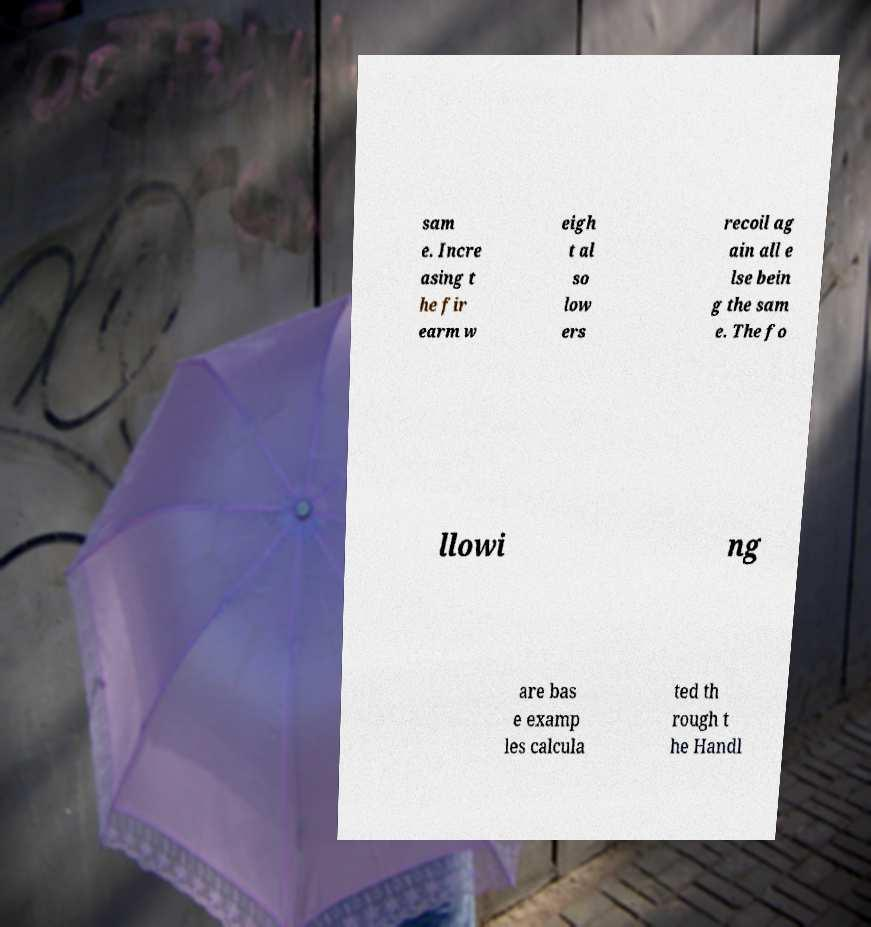Could you assist in decoding the text presented in this image and type it out clearly? sam e. Incre asing t he fir earm w eigh t al so low ers recoil ag ain all e lse bein g the sam e. The fo llowi ng are bas e examp les calcula ted th rough t he Handl 